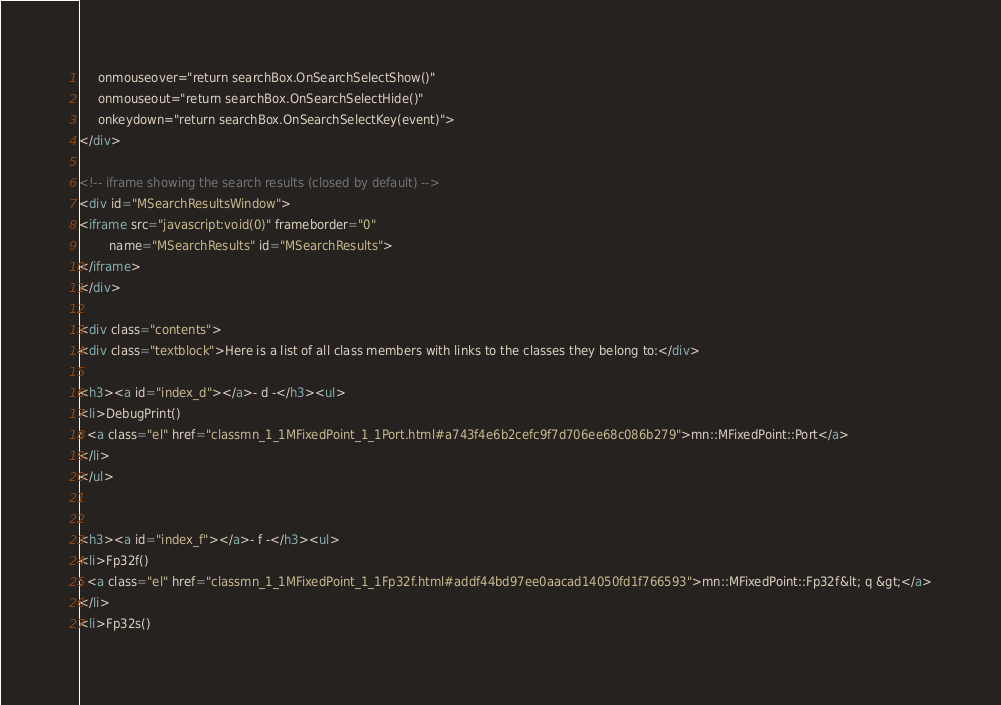Convert code to text. <code><loc_0><loc_0><loc_500><loc_500><_HTML_>     onmouseover="return searchBox.OnSearchSelectShow()"
     onmouseout="return searchBox.OnSearchSelectHide()"
     onkeydown="return searchBox.OnSearchSelectKey(event)">
</div>

<!-- iframe showing the search results (closed by default) -->
<div id="MSearchResultsWindow">
<iframe src="javascript:void(0)" frameborder="0" 
        name="MSearchResults" id="MSearchResults">
</iframe>
</div>

<div class="contents">
<div class="textblock">Here is a list of all class members with links to the classes they belong to:</div>

<h3><a id="index_d"></a>- d -</h3><ul>
<li>DebugPrint()
: <a class="el" href="classmn_1_1MFixedPoint_1_1Port.html#a743f4e6b2cefc9f7d706ee68c086b279">mn::MFixedPoint::Port</a>
</li>
</ul>


<h3><a id="index_f"></a>- f -</h3><ul>
<li>Fp32f()
: <a class="el" href="classmn_1_1MFixedPoint_1_1Fp32f.html#addf44bd97ee0aacad14050fd1f766593">mn::MFixedPoint::Fp32f&lt; q &gt;</a>
</li>
<li>Fp32s()</code> 